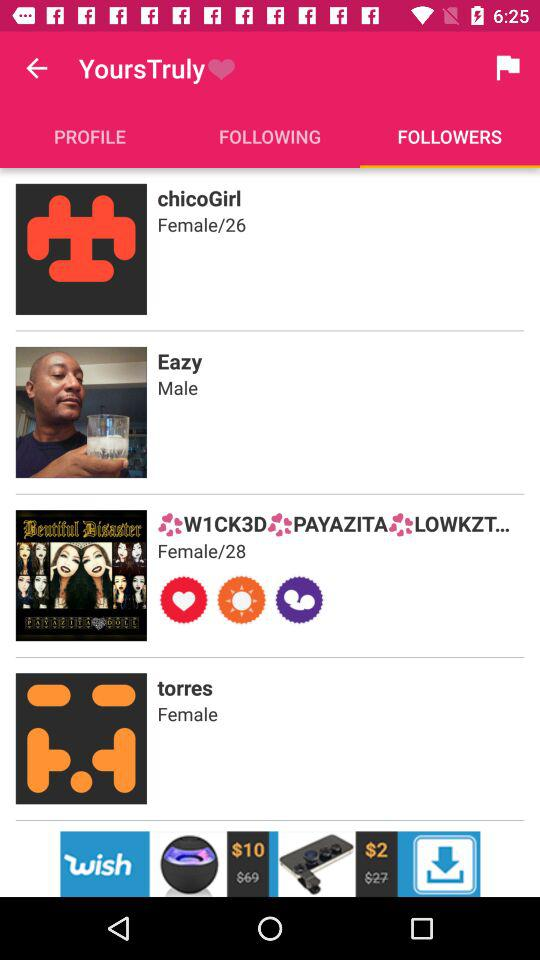What is the age of "chicoGirl"? The age of "chicoGirl" is 26. 